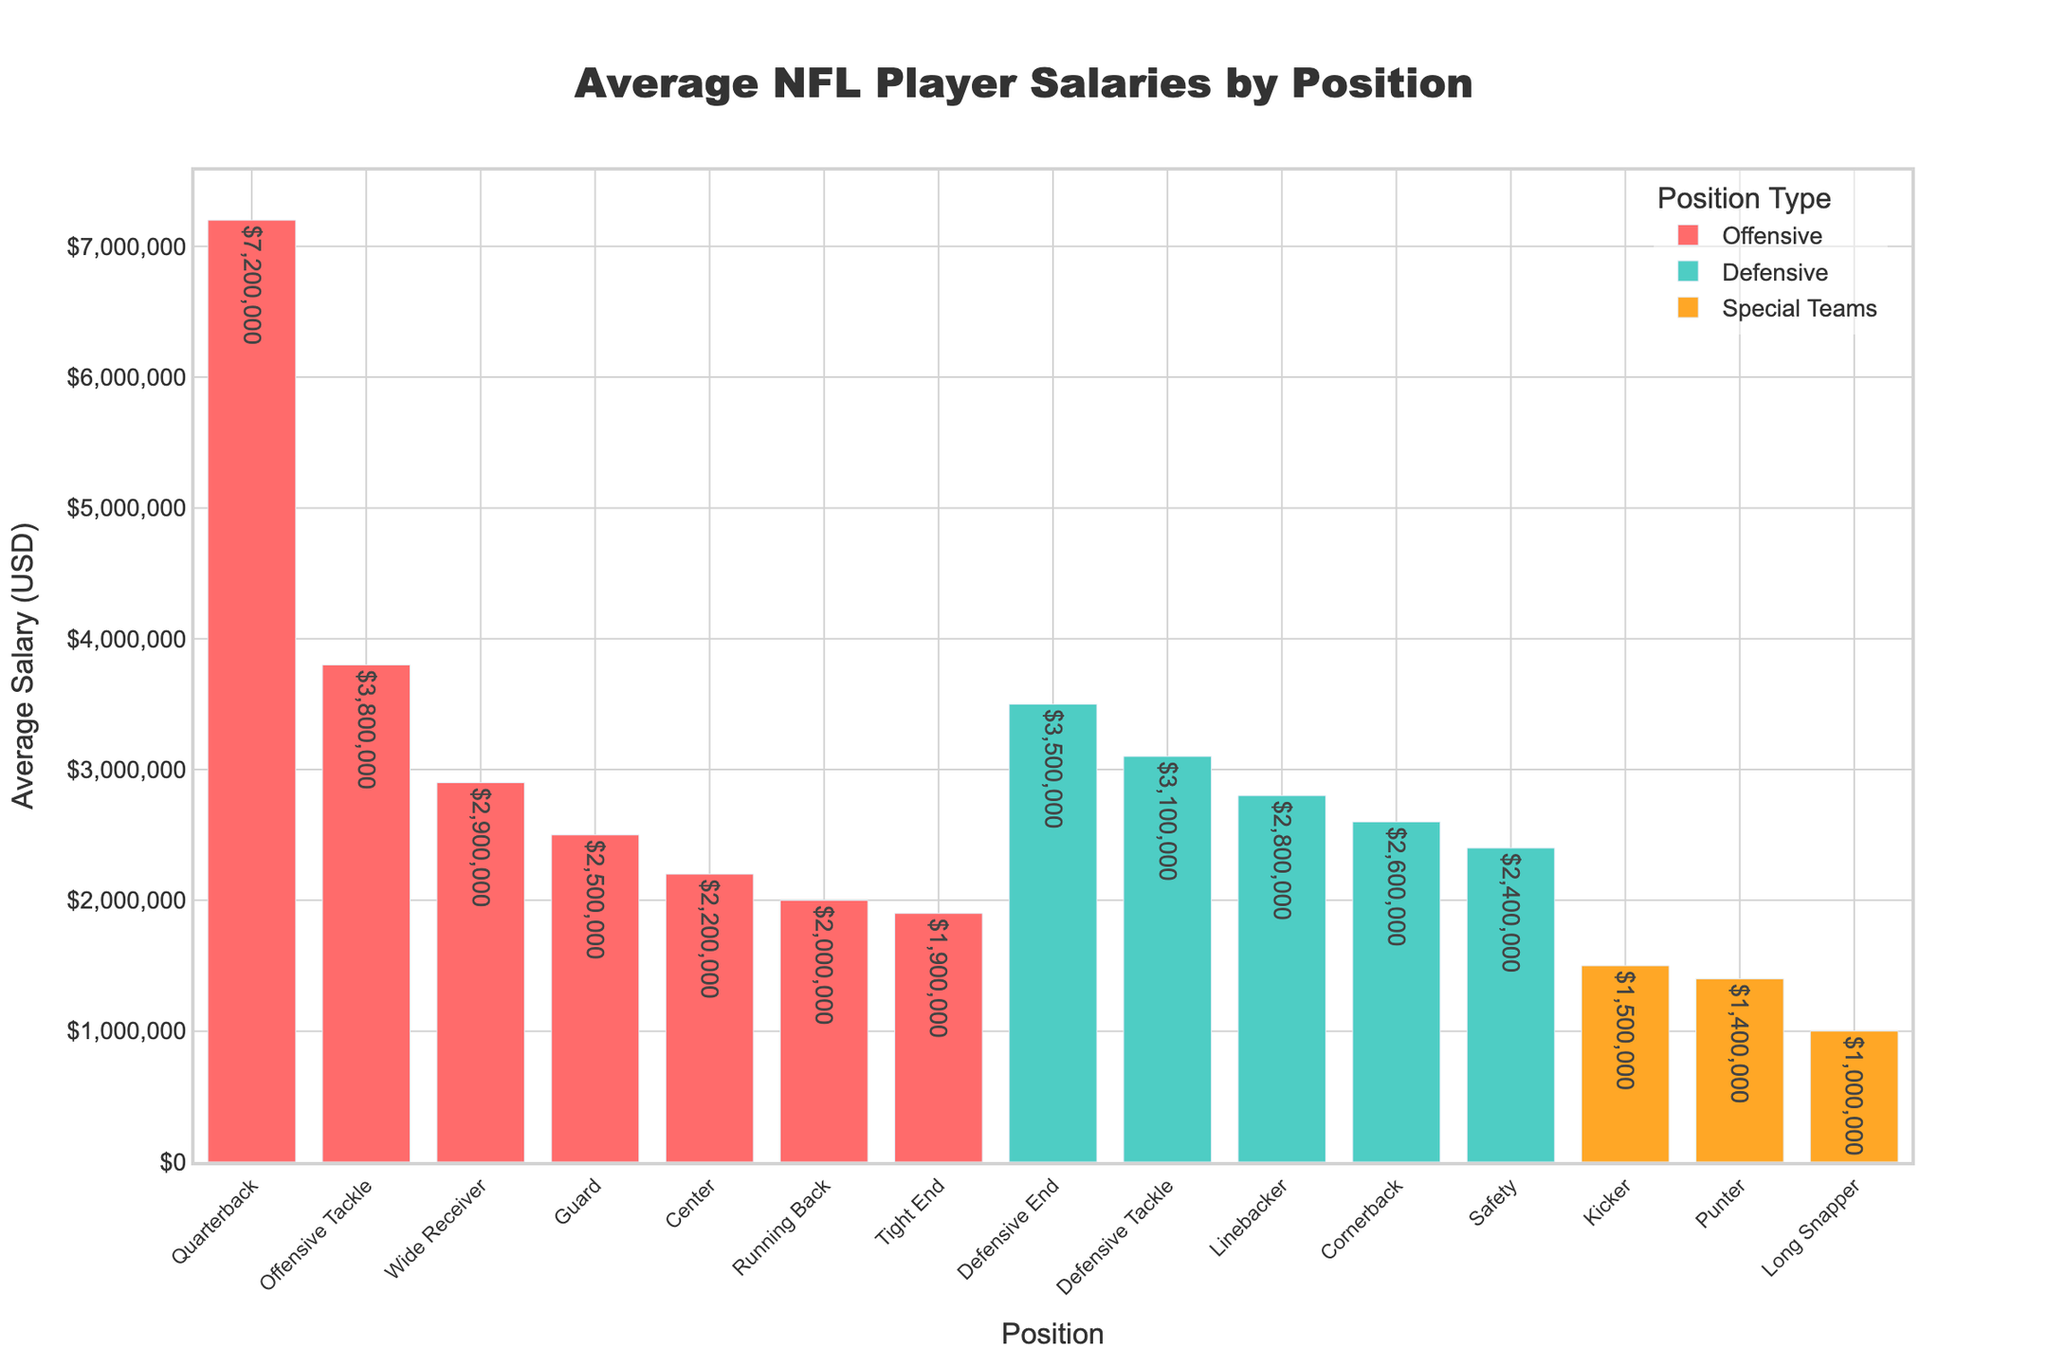Which position has the highest average salary? The tallest bar represents the position with the highest average salary, which is the Quarterback position.
Answer: Quarterback Which two defensive positions have the highest average salaries, and what are their respective values? By looking at the green bars, the tallest ones correspond to Defensive End and Defensive Tackle, with average salaries of $3,500,000 and $3,100,000 respectively.
Answer: Defensive End: $3,500,000; Defensive Tackle: $3,100,000 What is the difference in average salary between a Quarterback and a Running Back? The average salary of a Quarterback is $7,200,000 and that of a Running Back is $2,000,000. The difference is $7,200,000 - $2,000,000 = $5,200,000.
Answer: $5,200,000 How does the average salary of a Linebacker compare to that of a Wide Receiver? The bar for Wide Receiver shows an average salary of $2,900,000, while the bar for Linebacker shows $2,800,000. The Wide Receiver has a slightly higher salary.
Answer: Wide Receiver: $2,900,000 > Linebacker: $2,800,000 Is the average salary of a Guard higher or lower than that of a Center, and by how much? The average salary of a Guard is $2,500,000, while that of a Center is $2,200,000. The difference is $2,500,000 - $2,200,000 = $300,000.
Answer: Guard is higher by $300,000 Which group (Offensive, Defensive, or Special Teams) has the highest average salary, and what is the position? The highest bar overall is for the Quarterback position, which falls under the Offensive group.
Answer: Offensive, Quarterback What is the sum of the average salaries for the positions within Special Teams? The average salaries are Kicker: $1,500,000, Punter: $1,400,000, and Long Snapper: $1,000,000. The sum is $1,500,000 + $1,400,000 + $1,000,000 = $3,900,000.
Answer: $3,900,000 Which position has the lowest average salary, and what is its value? The shortest bar represents the position with the lowest average salary, which is the Long Snapper position at $1,000,000.
Answer: Long Snapper: $1,000,000 What is the combined average salary for the offensive positions Tight End and Wide Receiver? The average salary for a Tight End is $1,900,000 and for a Wide Receiver is $2,900,000. The combined salary is $1,900,000 + $2,900,000 = $4,800,000.
Answer: $4,800,000 